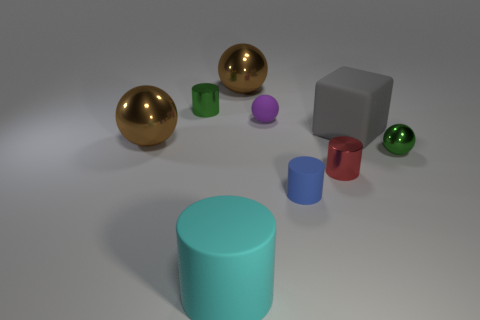There is a tiny object that is the same color as the small metal ball; what material is it?
Offer a very short reply. Metal. What shape is the object that is the same color as the tiny metal ball?
Provide a succinct answer. Cylinder. The big shiny object to the left of the cyan rubber thing is what color?
Offer a terse response. Brown. What number of things are either shiny balls that are on the right side of the red object or big metallic things behind the gray matte cube?
Ensure brevity in your answer.  2. How many other matte objects are the same shape as the big cyan matte object?
Offer a very short reply. 1. What color is the block that is the same size as the cyan matte cylinder?
Keep it short and to the point. Gray. The small cylinder that is behind the metal sphere that is in front of the big metal ball to the left of the cyan cylinder is what color?
Give a very brief answer. Green. Does the purple rubber thing have the same size as the green metal object that is on the left side of the tiny green shiny sphere?
Ensure brevity in your answer.  Yes. How many objects are either big metallic spheres or big cylinders?
Offer a terse response. 3. Is there a blue object made of the same material as the cyan thing?
Your answer should be compact. Yes. 